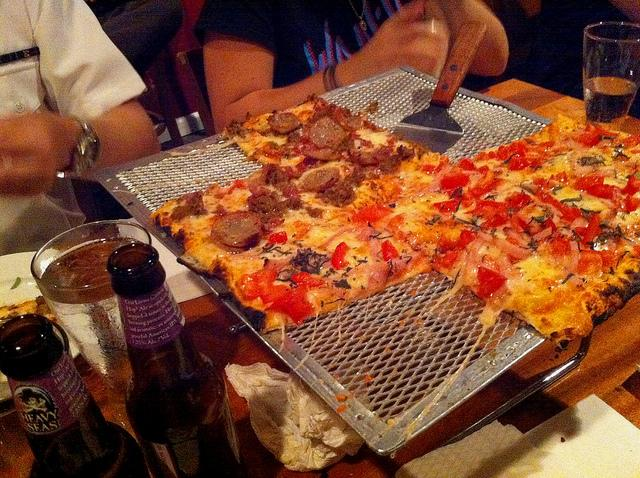What is the topping shown? Please explain your reasoning. bell pepper. This is a common pizza topping. the pepper shown is of the red colored variety. 